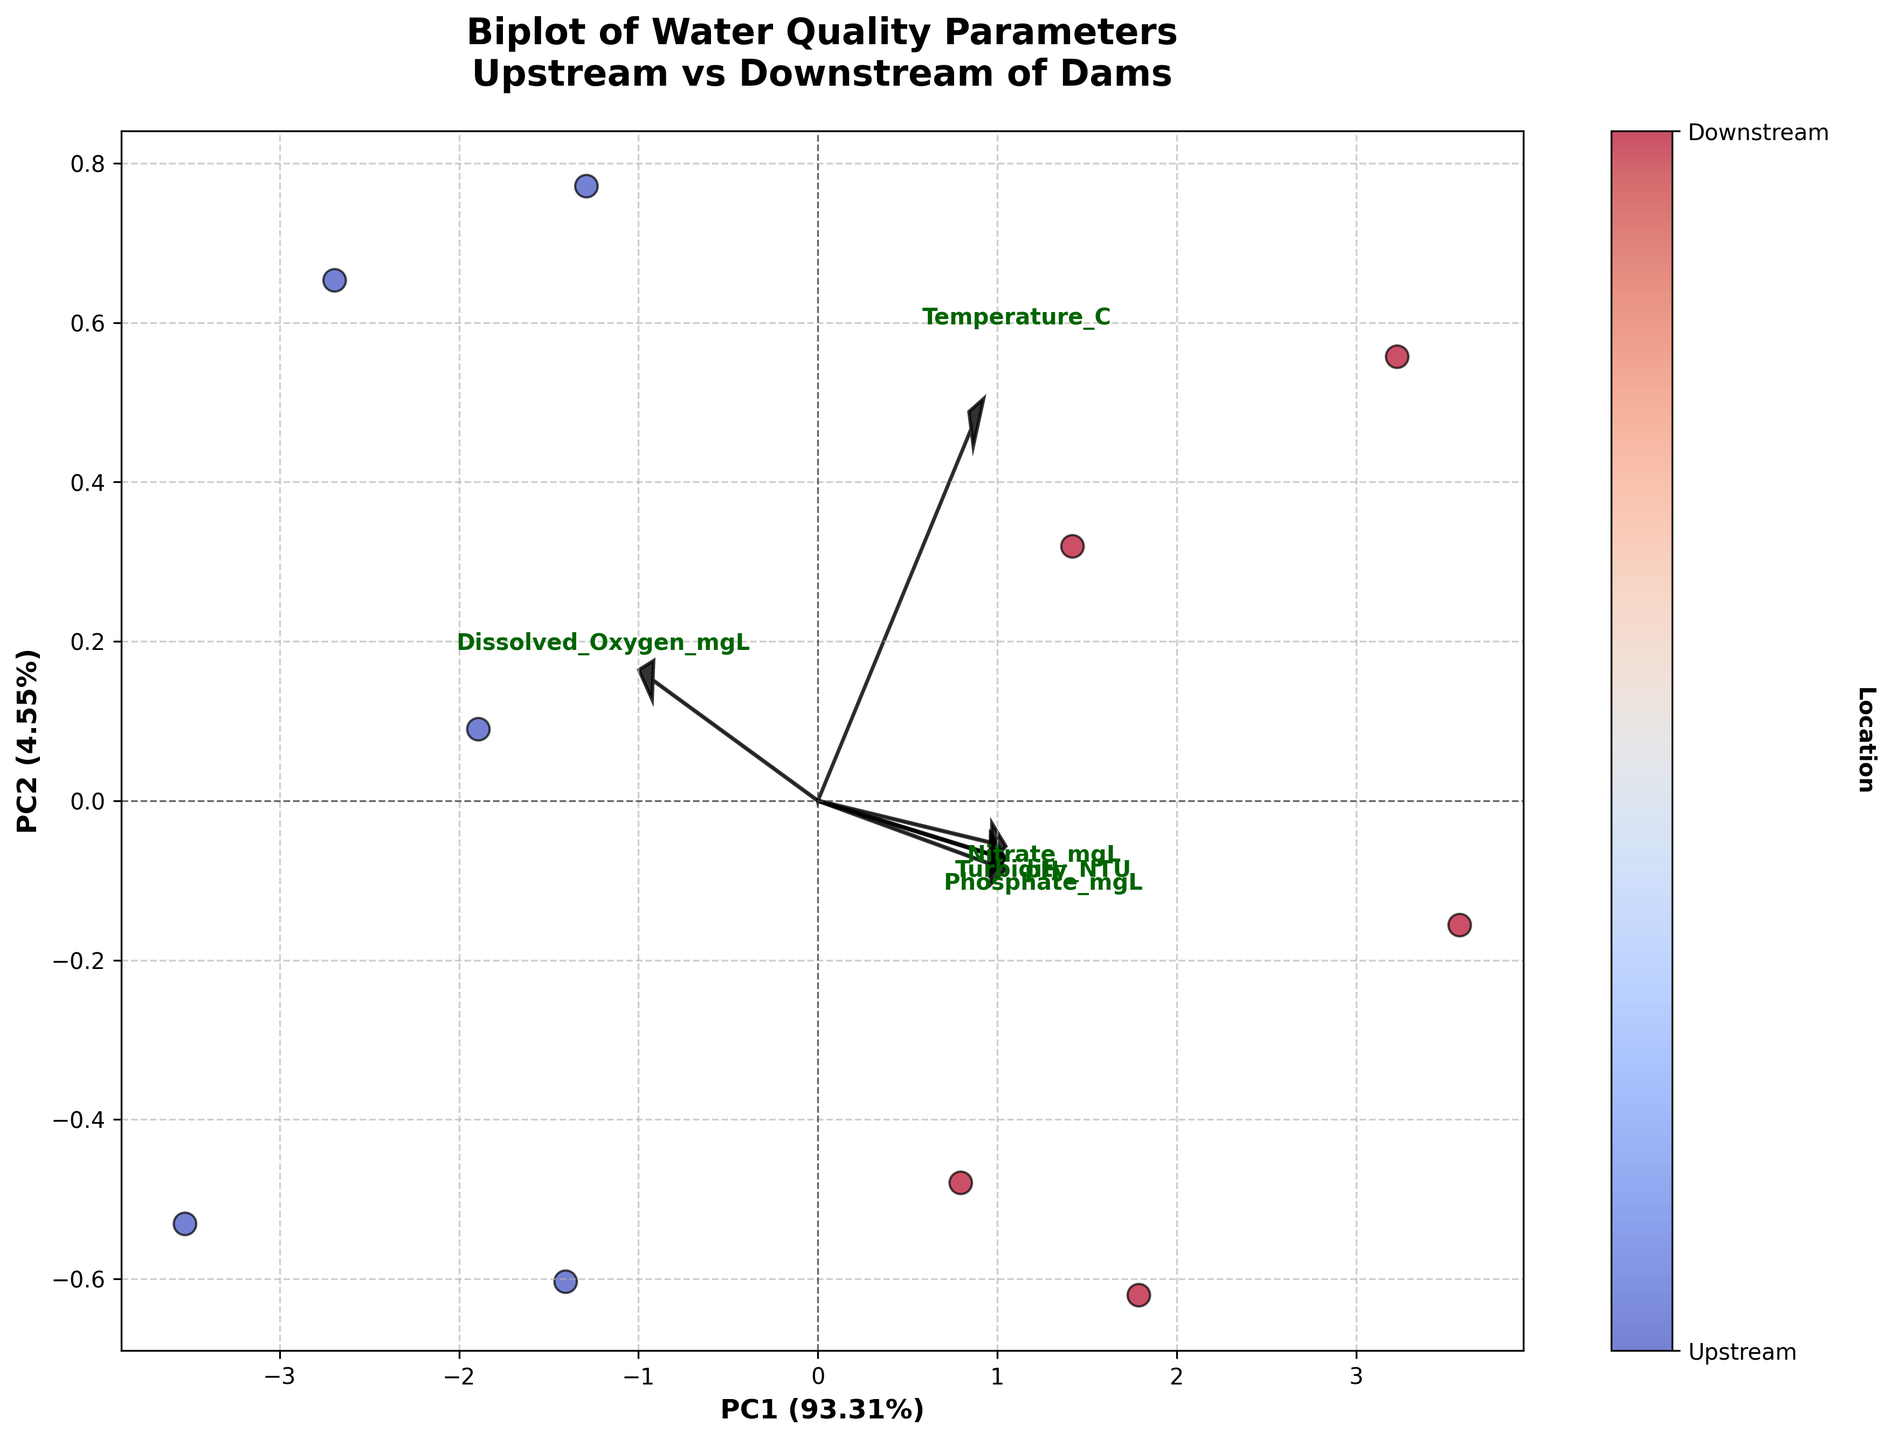What is the title of the plot? The title is typically positioned at the top of the plot. Reading from the top of the figure, the title is "Biplot of Water Quality Parameters\nUpstream vs Downstream of Dams"
Answer: Biplot of Water Quality Parameters\nUpstream vs Downstream of Dams How many components are visualized in the biplot? Biplots usually depict two principal components, labeled on both the X and Y axes. Here, the X-axis is labeled as 'PC1' and the Y-axis as 'PC2', so there are 2 components visualized.
Answer: 2 Which axis represents the first principal component, and what is its explained variance? Principal components are labeled on each axis. The X-axis label indicates it represents 'PC1' and includes the explained variance percentage in parentheses. Here, PC1 is on the X-axis with an explained variance of 58.32%.
Answer: X-axis, 58.32% What does the colorbar represent? The colorbar typically is adjacent to the plot and corresponds to some variable differentiated through the color gradient or category. The colorbar shows two ticks labeled 'Upstream' and 'Downstream', along with a label 'Location'. Hence, it represents different locations, specifically upstream and downstream of dams.
Answer: Location (Upstream and Downstream) How are 'Upstream' and 'Downstream' data points differentiated on the plot? Points can be differentiated by color and sometimes by label or symbol. According to the colorbar along the figure and the color distinction in the scatter, 'Downstream' points appear to be represented by warmer colors (reddish) and 'Upstream' by cooler colors (bluish).
Answer: By color: Blue for Upstream and Red for Downstream Which water quality parameter seems to have the highest loading on PC1? Loadings can be inferred by the length and direction of arrows from the origin. The vector with the highest projection on the PC1 axis gives the highest loading on PC1. Here, 'Nitrate' appears to have the largest arrow projection on the PC1 axis.
Answer: Nitrate Is there a noticeable pattern in the clustering of upstream and downstream data points? By examining the spatial arrangement of points and color distributions, downstream points (reddish) tend to cluster towards one side of the first principal component, while upstream points (bluish) congregate on the opposite side. This indicates a possible separation based on PC1.
Answer: Yes, upstream and downstream points are separately clustered What are the loadings for 'Dissolved Oxygen' on PC1 and PC2? To find the loadings, one must look at which direction the arrow for 'Dissolved Oxygen' points. It is necessary to analyze the coordinates where the arrow ends relative to PC1 (horizontal) and PC2 (vertical) axes. Observing the plot, 'Dissolved Oxygen' has a loading that is positive on PC1 and negative on PC2.
Answer: Positive on PC1, Negative on PC2 Among the listed parameters, which vector is closest to the origin, and what does that imply? The distance of vectors from the origin shows the strength of their contribution to principal components. The 'Phosphate' vector is shortest, indicating it has the least influence on the variance captured by PC1 and PC2.
Answer: Phosphate, least influence 